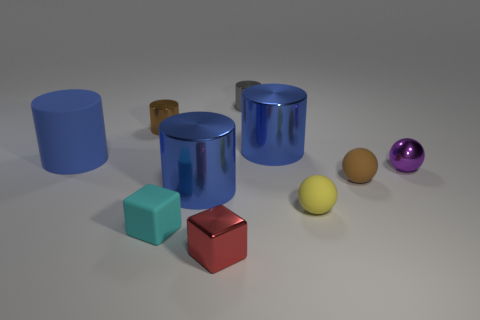Subtract all blue cylinders. How many were subtracted if there are1blue cylinders left? 2 Subtract all green balls. How many blue cylinders are left? 3 Subtract all gray shiny cylinders. How many cylinders are left? 4 Subtract all brown cylinders. How many cylinders are left? 4 Subtract all gray cylinders. Subtract all cyan cubes. How many cylinders are left? 4 Subtract all balls. How many objects are left? 7 Add 7 cyan rubber cubes. How many cyan rubber cubes are left? 8 Add 5 purple balls. How many purple balls exist? 6 Subtract 1 cyan cubes. How many objects are left? 9 Subtract all big blue metallic cubes. Subtract all tiny balls. How many objects are left? 7 